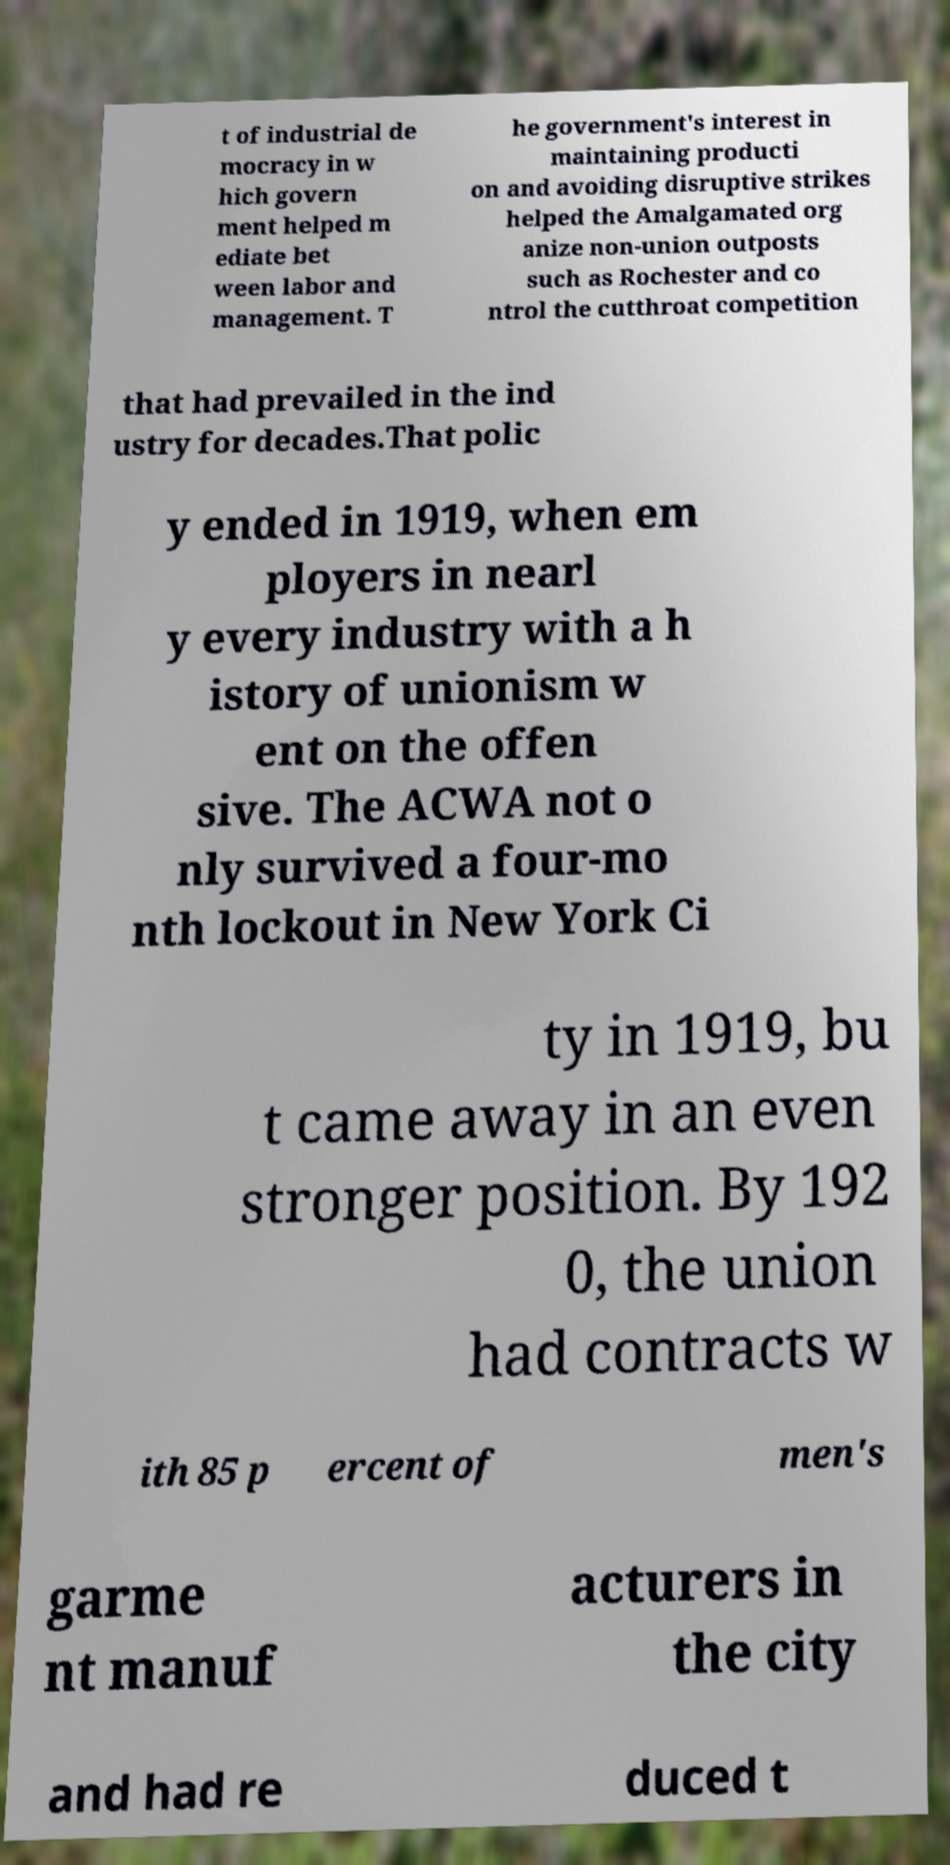What messages or text are displayed in this image? I need them in a readable, typed format. t of industrial de mocracy in w hich govern ment helped m ediate bet ween labor and management. T he government's interest in maintaining producti on and avoiding disruptive strikes helped the Amalgamated org anize non-union outposts such as Rochester and co ntrol the cutthroat competition that had prevailed in the ind ustry for decades.That polic y ended in 1919, when em ployers in nearl y every industry with a h istory of unionism w ent on the offen sive. The ACWA not o nly survived a four-mo nth lockout in New York Ci ty in 1919, bu t came away in an even stronger position. By 192 0, the union had contracts w ith 85 p ercent of men's garme nt manuf acturers in the city and had re duced t 